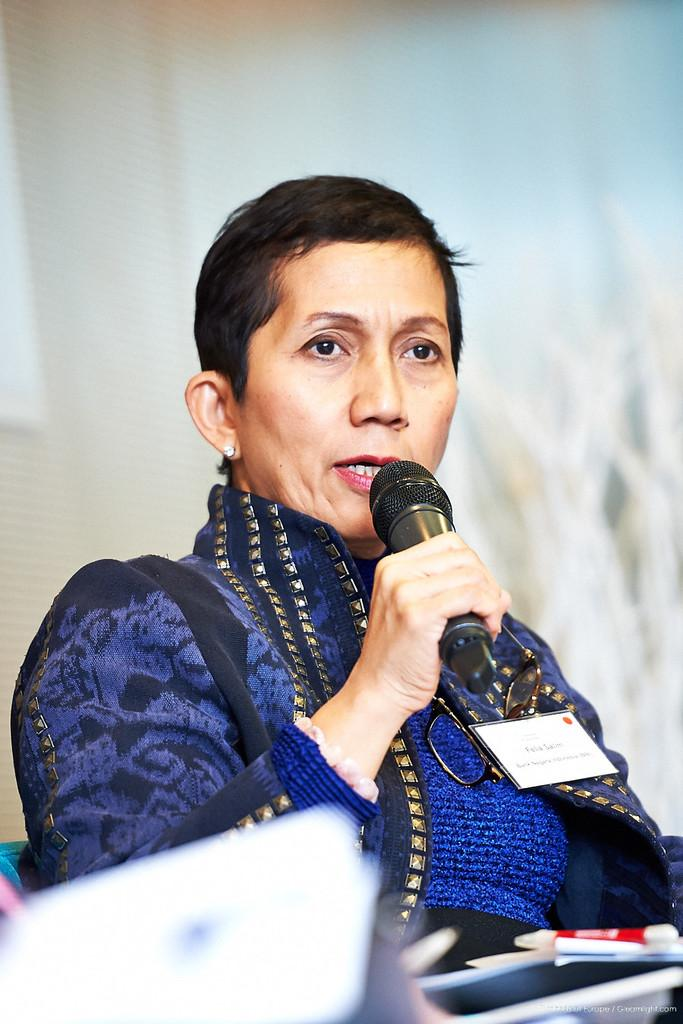Who is the main subject in the image? There is a woman in the image. What is the woman doing in the image? The woman is sitting on a chair and holding a microphone. What can be seen in the background of the image? There is a wall in the background of the image. How many beds are visible in the image? There are no beds present in the image. What point is the woman trying to make in the image? The image does not provide any context or information about the woman's intentions or the point she might be trying to make. 